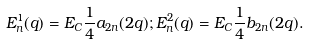<formula> <loc_0><loc_0><loc_500><loc_500>E _ { n } ^ { 1 } ( q ) = E _ { C } \frac { 1 } { 4 } a _ { 2 n } ( 2 q ) ; E _ { n } ^ { 2 } ( q ) = E _ { C } \frac { 1 } { 4 } b _ { 2 n } ( 2 q ) .</formula> 